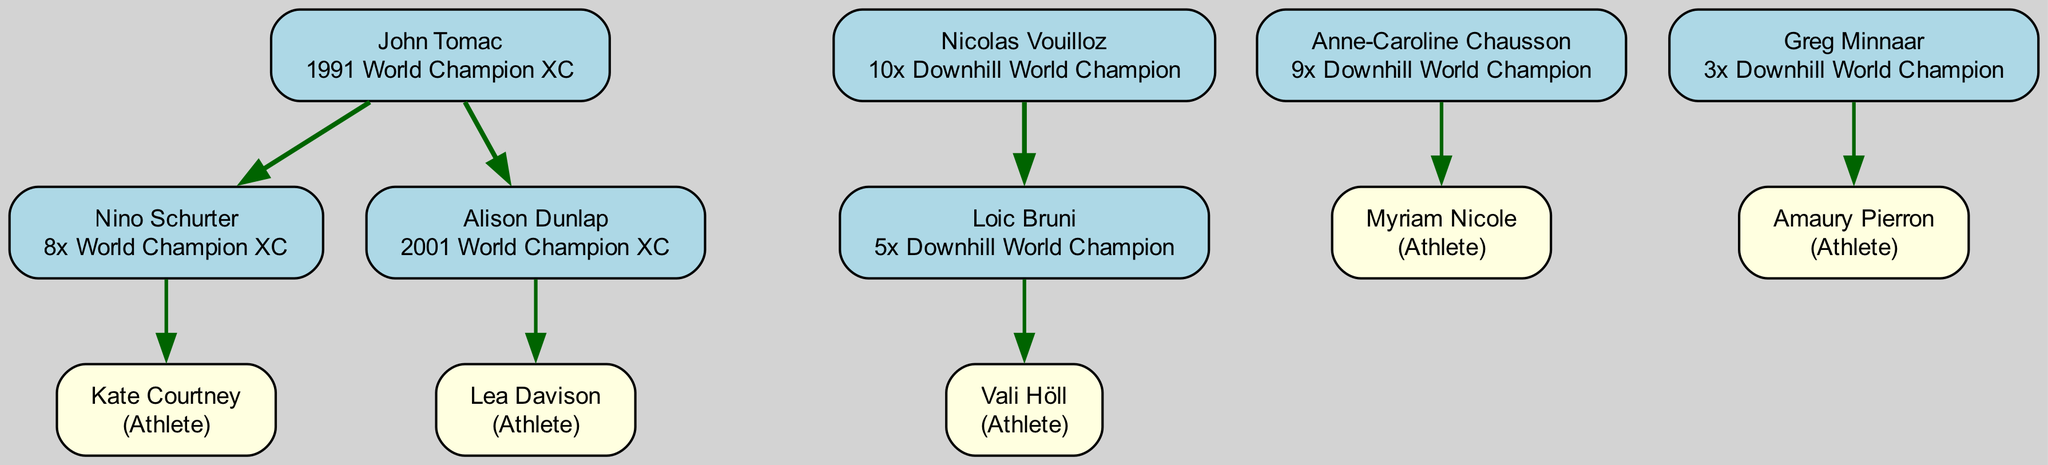What is the achievement of John Tomac? The diagram shows that John Tomac is noted for being the 1991 World Champion XC.
Answer: 1991 World Champion XC How many athletes did Nino Schurter coach? By reviewing the coaching lineage, Nino Schurter coached one athlete, Kate Courtney.
Answer: 1 Who coached Loic Bruni? The diagram indicates that Loic Bruni was coached by Nicolas Vouilloz.
Answer: Nicolas Vouilloz What is the total number of world championships won by Anne-Caroline Chausson? Looking at her node, she is noted for 9 world championships, making it clear she has a total of 9 titles.
Answer: 9 Which athlete is coached by Alison Dunlap? According to the diagram, Alison Dunlap coached Lea Davison.
Answer: Lea Davison Which coach has the most notable achievements listed? By comparing the notable achievements displayed, Nicolas Vouilloz has the highest count with 10 Downhill World Champion titles.
Answer: 10x Downhill World Champion How many total coaches are represented in the diagram? Counting the nodes labeled as coaches, there are a total of 6 distinct coaches identifiable in the diagram.
Answer: 6 What is the relationship between John Tomac and Nino Schurter? The diagram indicates that John Tomac is the coach of Nino Schurter, establishing a direct coaching lineage.
Answer: Coach Who is the athlete that Vali Höll was coached by? Based on the diagram, Vali Höll was coached by Loic Bruni.
Answer: Loic Bruni 